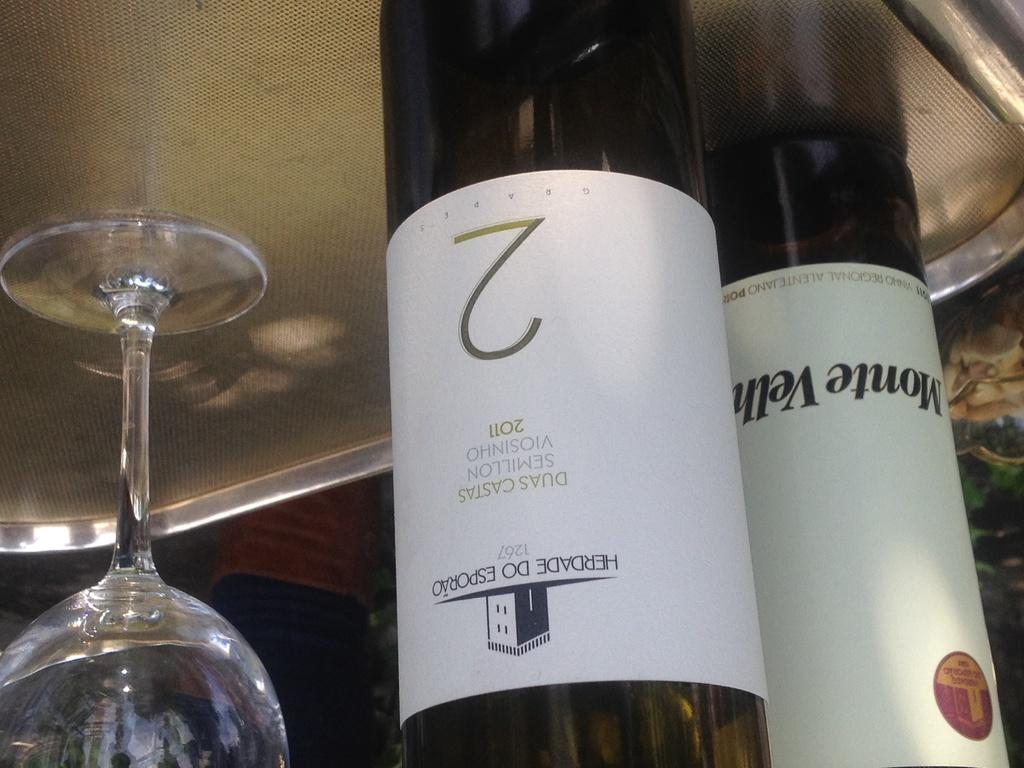Provide a one-sentence caption for the provided image. A bottole of Daus Castas and a bottle of Monte Velh sit on a tray with one glass. 